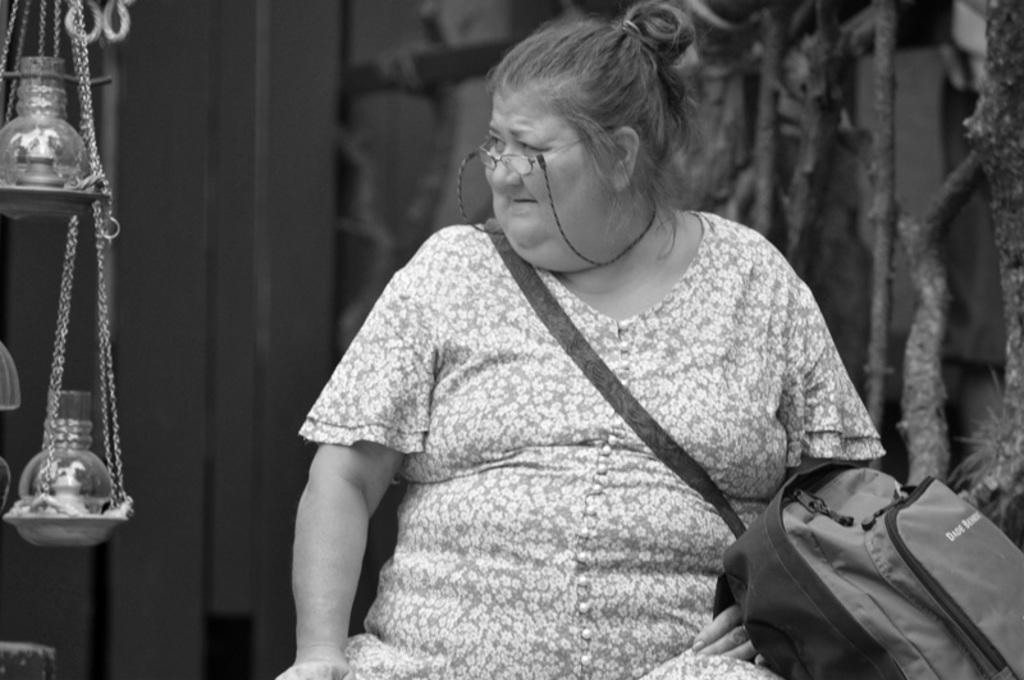What is the woman in the image doing? The woman is sitting in the image. What is the woman holding or carrying in the image? The woman is carrying a bag in the image. What else can be seen in the image besides the woman? There are objects visible in the image. What is the color scheme of the image? The image is black and white in color. How does the woman's muscle strength contribute to her voyage in the image? There is no mention of a voyage or muscle strength in the image, as it only shows a woman sitting and carrying a bag. 